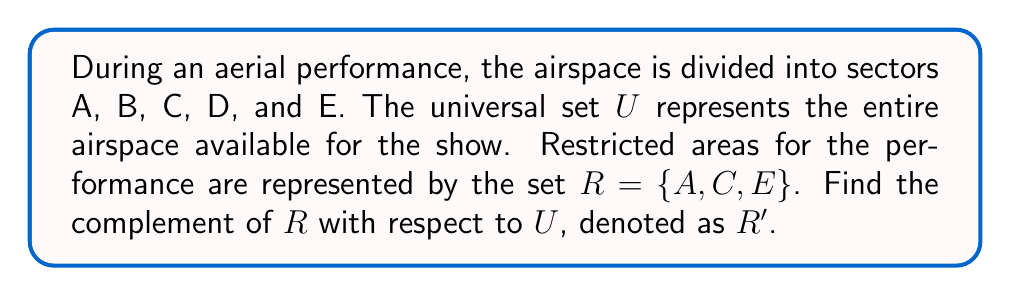Help me with this question. To solve this problem, we need to understand the concept of complement sets in set theory:

1. The complement of a set R with respect to the universal set U, denoted as R', contains all elements in U that are not in R.

2. In this case:
   U = {A, B, C, D, E} (the entire airspace available for the show)
   R = {A, C, E} (restricted areas)

3. To find R', we need to identify all elements in U that are not in R:
   R' = {x ∈ U | x ∉ R}

4. By comparing U and R, we can see that B and D are in U but not in R.

5. Therefore, R' = {B, D}

This means that sectors B and D are the areas where the acrobatic pilot can perform without restrictions during the aerial display.
Answer: R' = {B, D} 